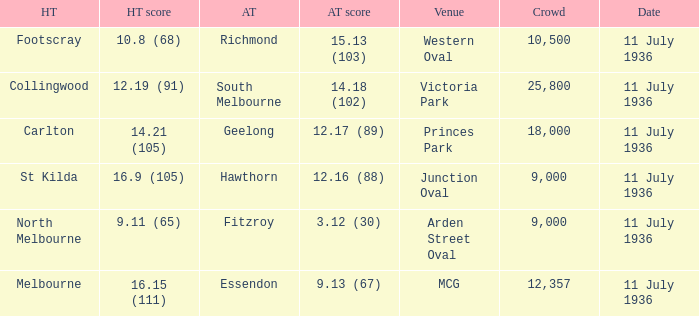What is the lowest crowd seen by the mcg Venue? 12357.0. 